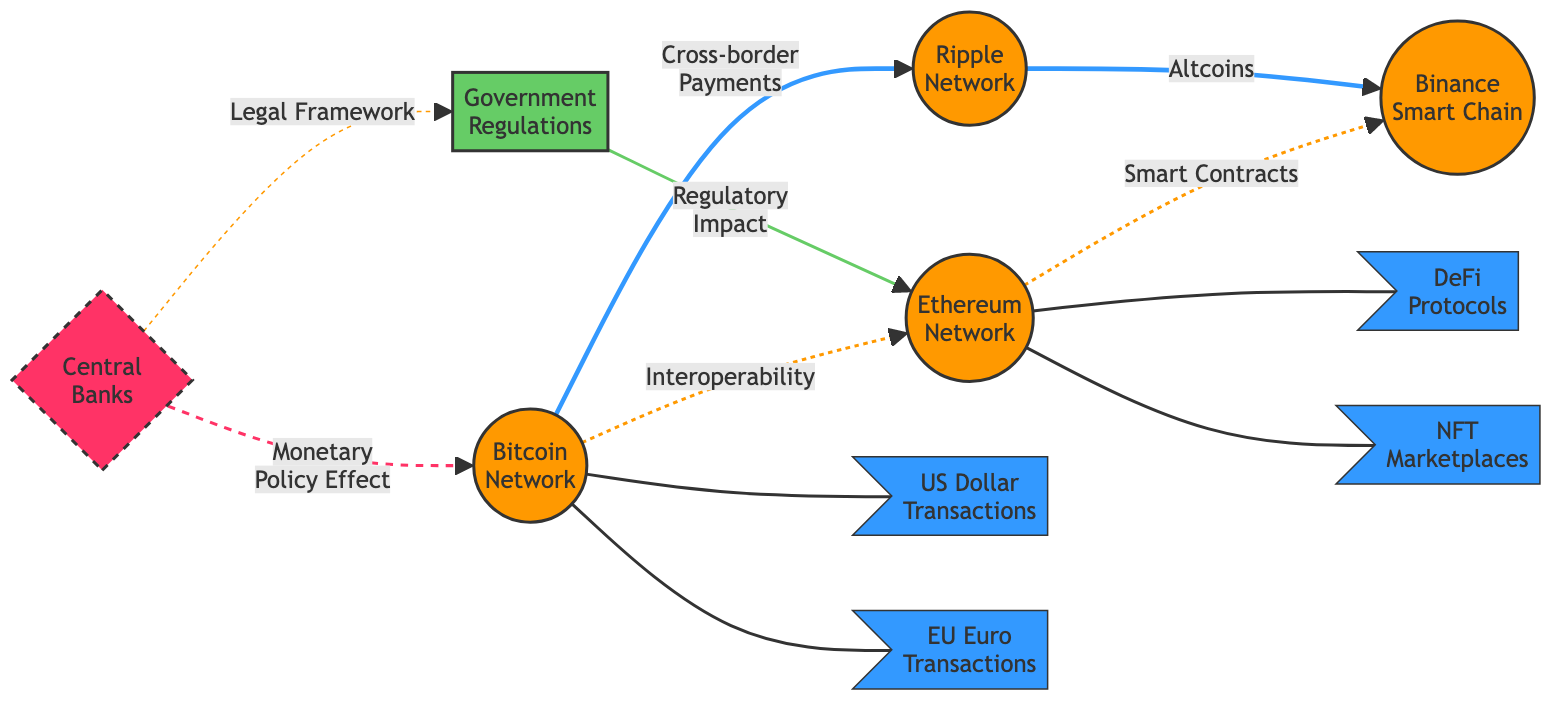What are the two key cryptocurrencies depicted in the diagram? The diagram clearly shows Bitcoin and Ethereum as the primary cryptocurrencies represented with the largest nodes.
Answer: Bitcoin, Ethereum How many total networks are represented in the diagram? By counting the nodes labeled as networks, we find that there are four major cryptocurrency networks shown: Bitcoin, Ethereum, Ripple, and Binance Smart Chain.
Answer: 4 What is the relationship indicated between Bitcoin and Ethereum? The diagram uses a dashed line to represent interoperability between Bitcoin and Ethereum, indicating a connection without direct transactions.
Answer: Interoperability Which node is connected with a solid line to the US Dollar transactions? The solid lines indicate a direct relationship, and Bitcoin is linked to US Dollar transactions, representing a direct interaction.
Answer: Bitcoin What regulatory aspect connects Central Banks to Ethereum? The solid line indicates a direct relationship where Central Banks influence Ethereum through regulatory impact, highlighting the significance of oversight in cryptocurrency transactions.
Answer: Regulatory Impact How many moon nodes are present in the diagram? The diagram features moon nodes representing various transaction types and protocols, which totals four: US Dollar Transactions, EU Euro Transactions, DeFi Protocols, and NFT Marketplaces.
Answer: 4 Which connection indicates a legal framework in the diagram? A dashed line represents a connection showing that Central Banks have a relation to Government Regulations, which suggests a legal framework impacting both entities.
Answer: Legal Framework What type of impact do the Central Banks have on Bitcoin according to the diagram? Central Banks have a monetary policy effect on Bitcoin, indicating their regulatory influence on the cryptocurrency's value and usage.
Answer: Monetary Policy Effect Which network is linked to the DeFi protocols? The diagram indicates that Ethereum is linked to DeFi protocols, showcasing its role in decentralized finance applications.
Answer: Ethereum 